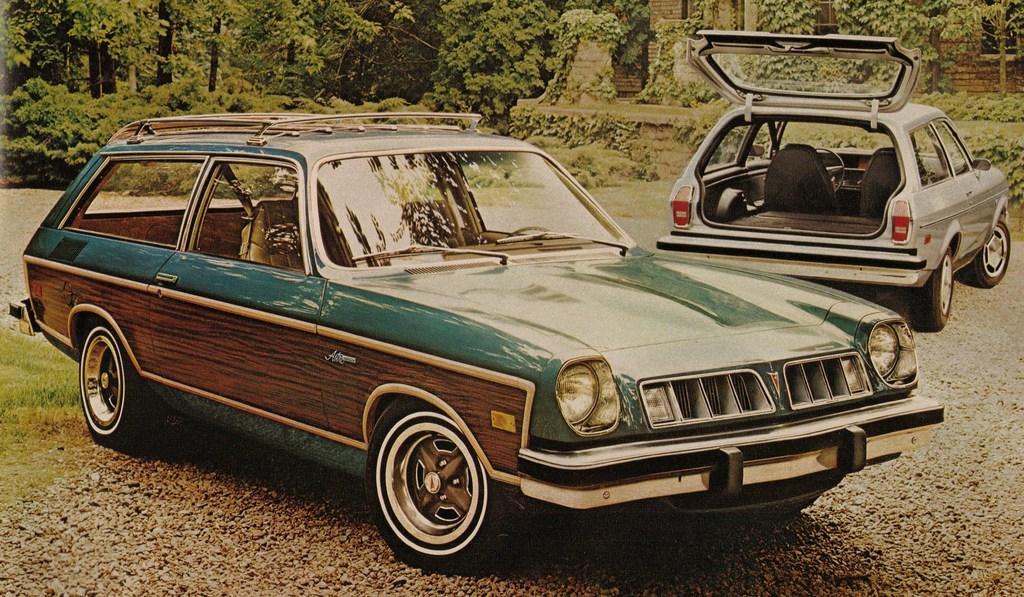Describe this image in one or two sentences. In this image, there are two cars, at the background there are some plants and trees, there is a house at the right side. 